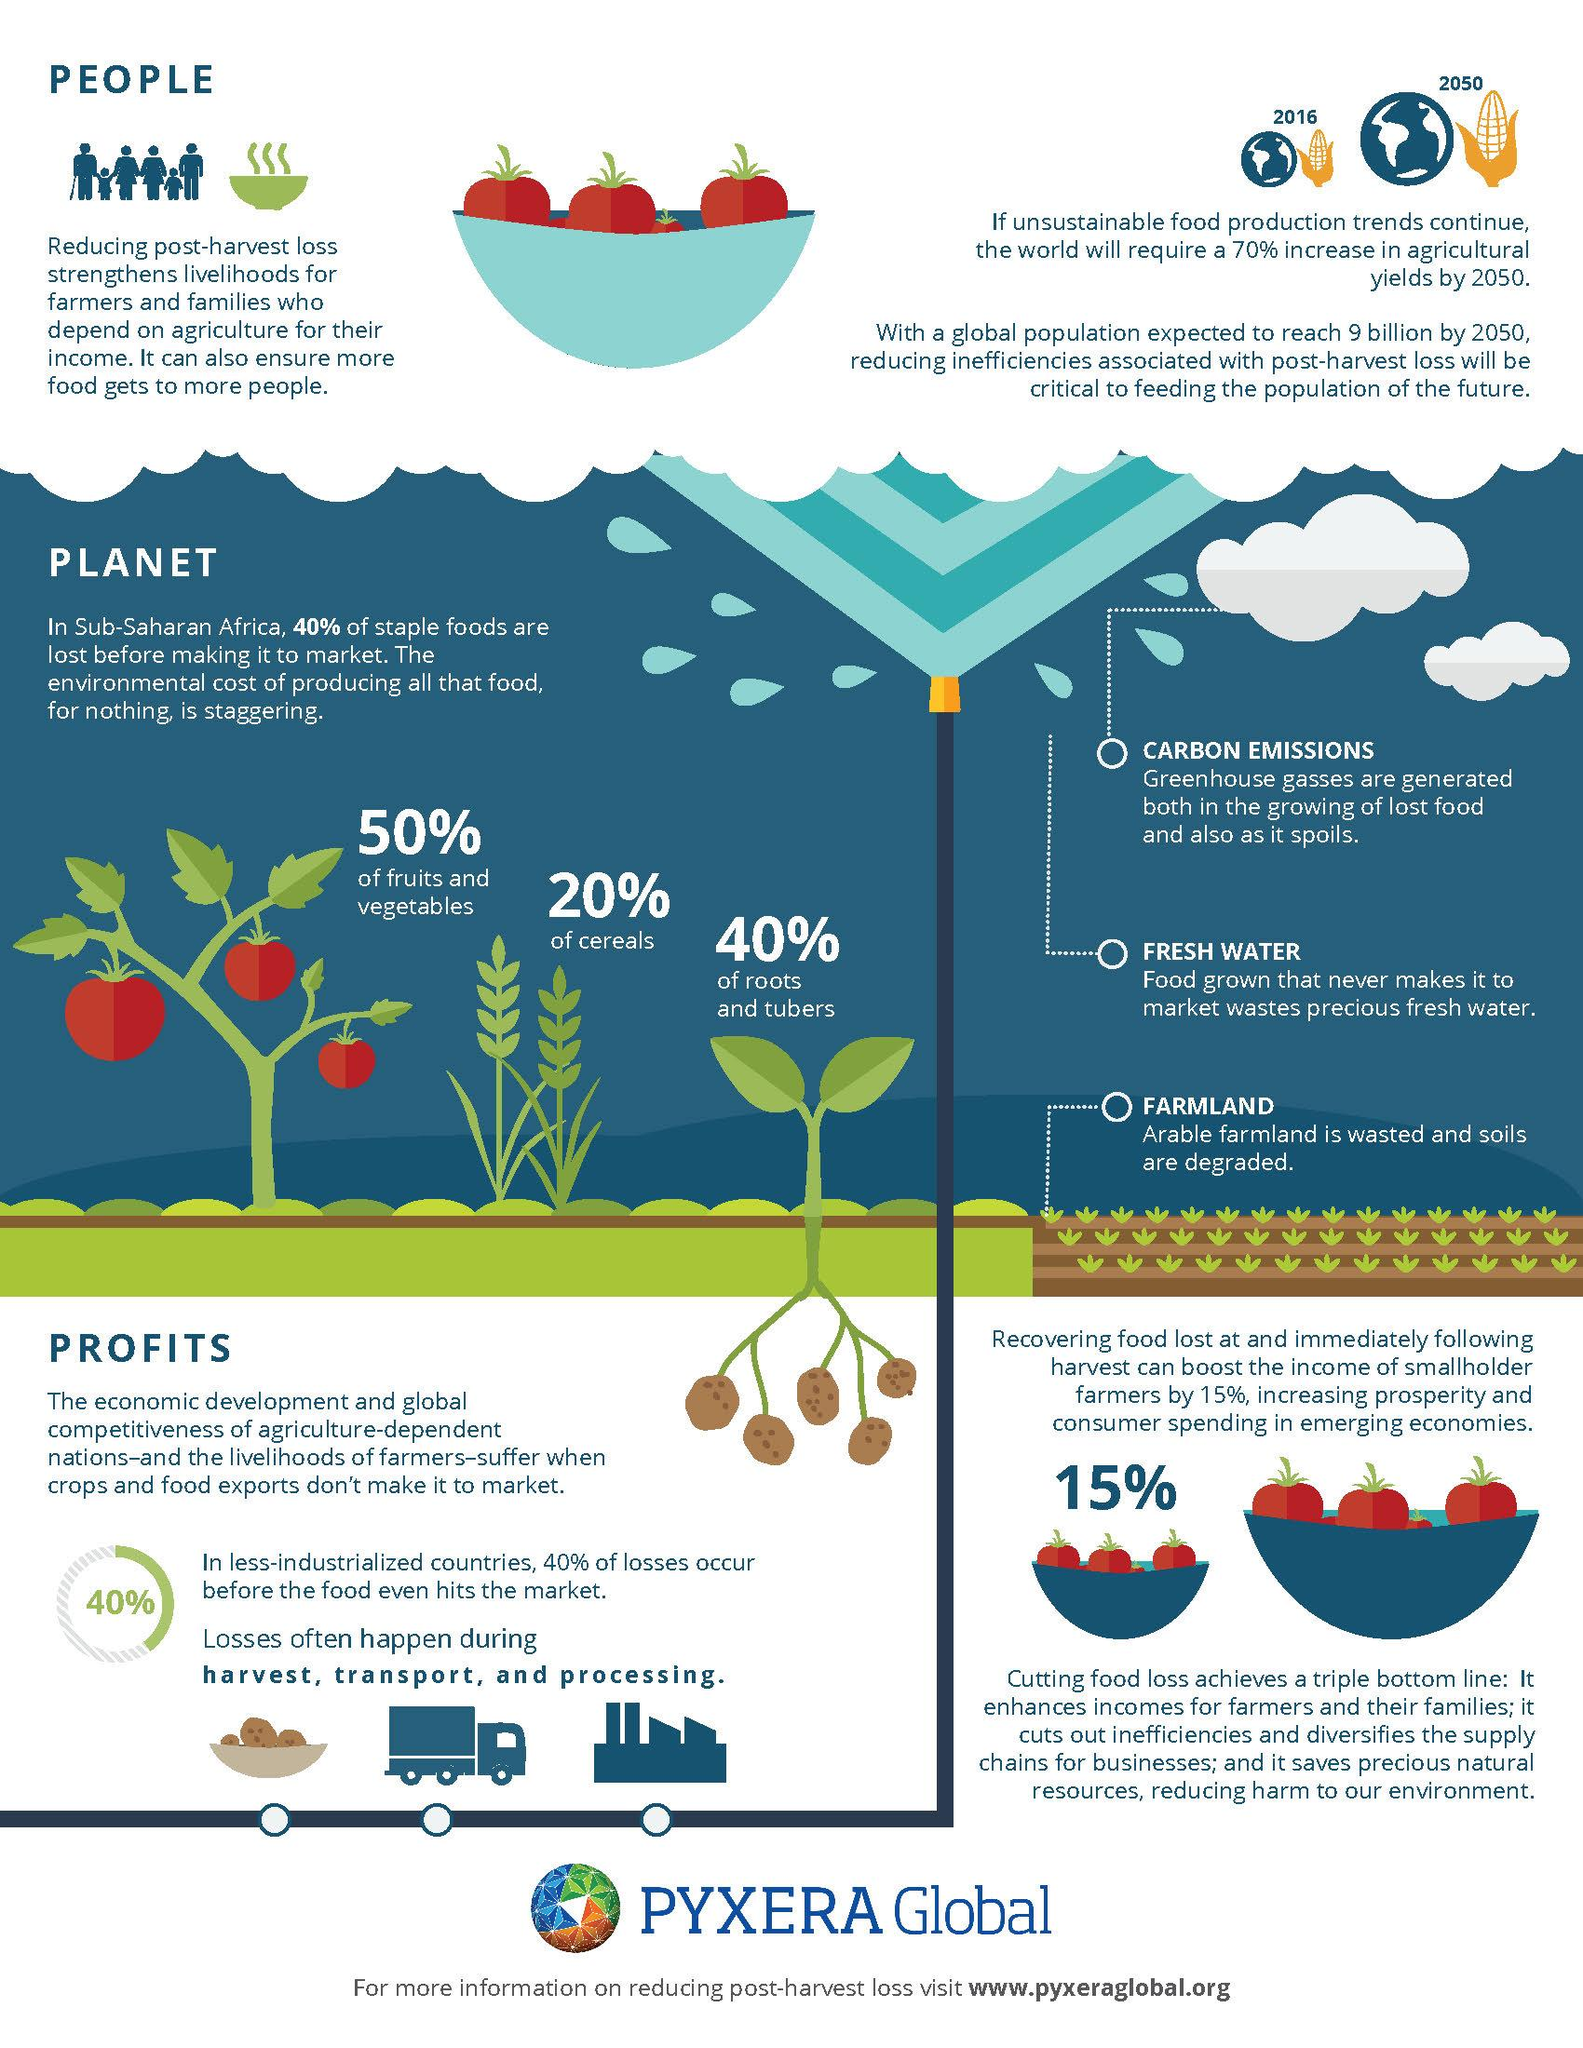Mention a couple of crucial points in this snapshot. According to data, approximately 80% of foods are not cereals. According to a recent study, only 40% of foods are roots and tubers. 